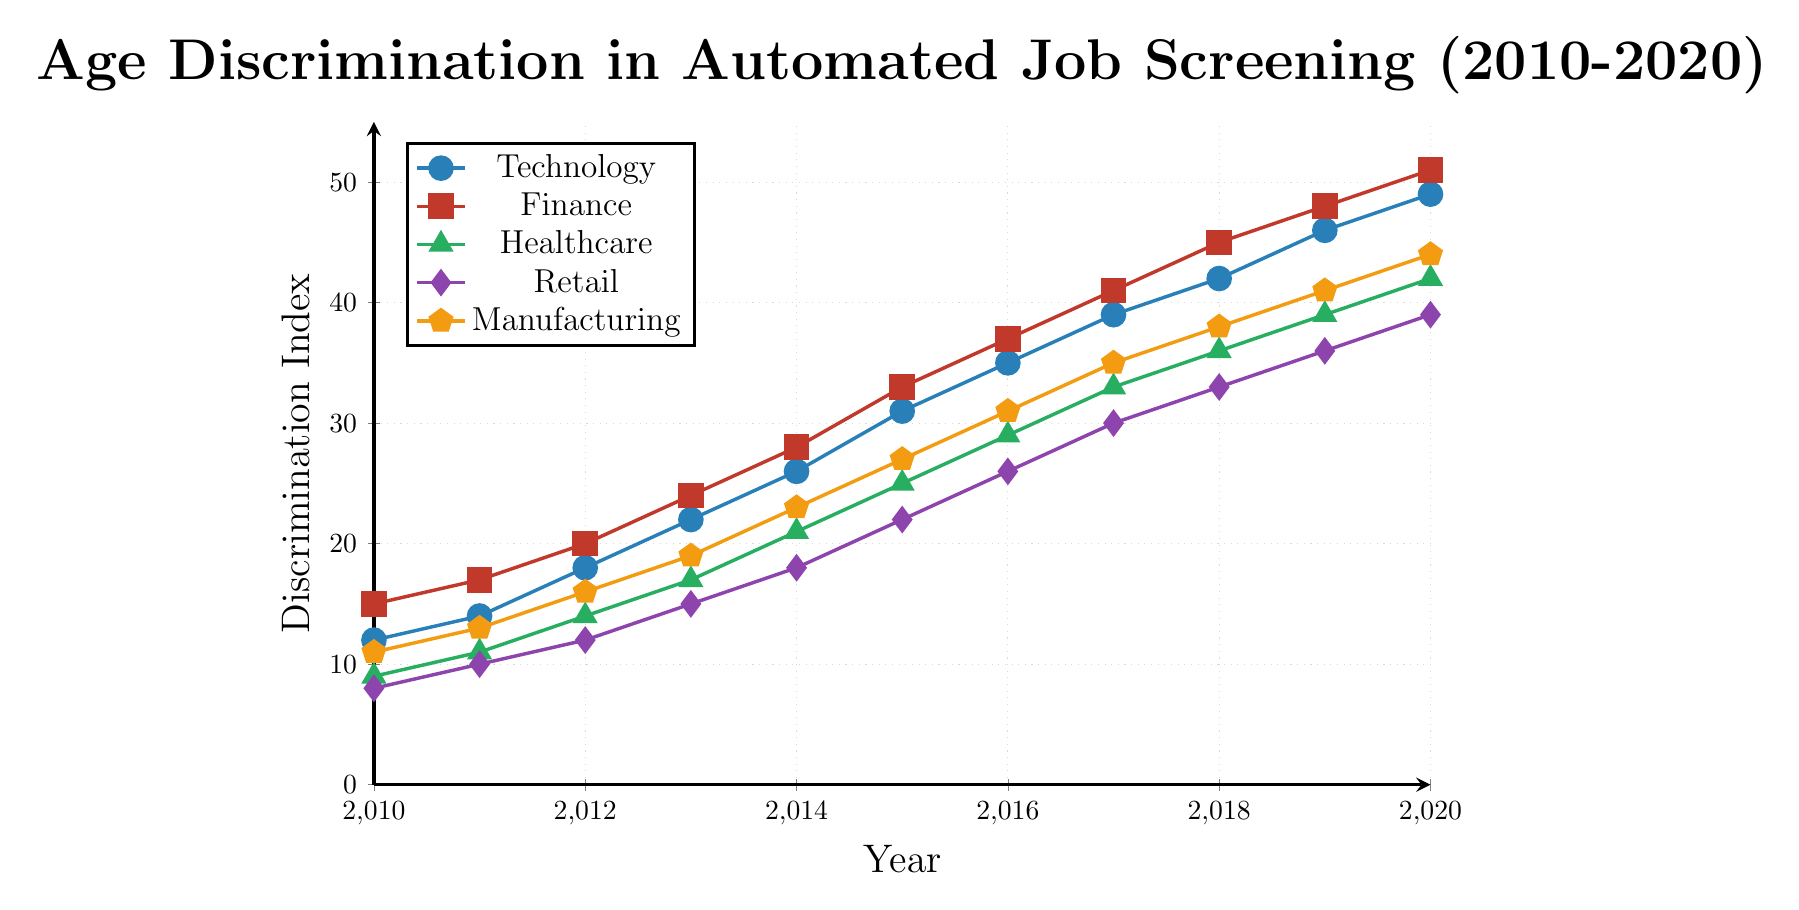Comparing the levels of age discrimination in the Healthcare and Finance industries in 2014, which industry had higher discrimination? To determine which industry had higher age discrimination in 2014, we look at the Discrimination Index values on the y-axis for both "Healthcare" and "Finance" at the x-axis value of 2014. Healthcare has a value of 21 whereas Finance has a value of 28, indicating higher discrimination in the Finance industry.
Answer: Finance Looking at the overall trends, which industry showed the most significant increase in age discrimination from 2010 to 2020? To determine which industry showed the largest increase, we calculate the difference in the Discrimination Index between 2020 and 2010 for each industry. Technology increased by 37 points (49-12), Finance by 36 points (51-15), Healthcare by 33 points (42-9), Retail by 31 points (39-8), and Manufacturing by 33 points (44-11). Thus, Technology showed the most significant increase.
Answer: Technology In 2018, what is the difference in the Discrimination Index between Technology and Retail? For 2018, the Discrimination Index for Technology is 42, and for Retail, it is 33. The difference is calculated as 42 - 33 = 9.
Answer: 9 On the chart, which industry is represented by green markers? To determine which industry is represented by green markers, we refer to the legend. The "Healthcare" industry is indicated by green markers.
Answer: Healthcare During which years did the Manufacturing industry show a Discrimination Index of 27 or above? Reviewing the vertical height of the Manufacturing industry line on the chart, a Discrimination Index of 27 or above starts from 2015 (27) onwards to 2020 (44). Therefore, the relevant years are 2015, 2016, 2017, 2018, 2019, and 2020.
Answer: 2015, 2016, 2017, 2018, 2019, 2020 What is the average Discrimination Index for the Retail industry over the period 2010-2020? The values for Retail from 2010 to 2020 are: 8, 10, 12, 15, 18, 22, 26, 30, 33, 36, and 39. Sum these values to get 249 and then divide by the number of years (11) to get the average: 249 / 11 = 22.63.
Answer: 22.63 Between 2015 and 2017, which industry experienced the highest absolute increase in age discrimination? Calculate each industry's increase from 2015 to 2017: Technology (39 - 31 = 8), Finance (41 - 33 = 8), Healthcare (33 - 25 = 8), Retail (30 - 22 = 8), Manufacturing (35 - 27 = 8). All industries experienced an equal increase of 8.
Answer: All industries (equal increase) Which year did the Technology industry reach a Discrimination Index of 31? Referring to the Technology industry line on the x-axis of the chart, the Technology industry reached a Discrimination Index of 31 in the year 2015.
Answer: 2015 By how many points did the Discrimination Index for Finance exceed the Discrimination Index for Retail in 2020? Refer to the values for Finance and Retail in 2020. Finance is at 51 points and Retail at 39 points. Subtract Retail from Finance: 51 - 39 = 12.
Answer: 12 